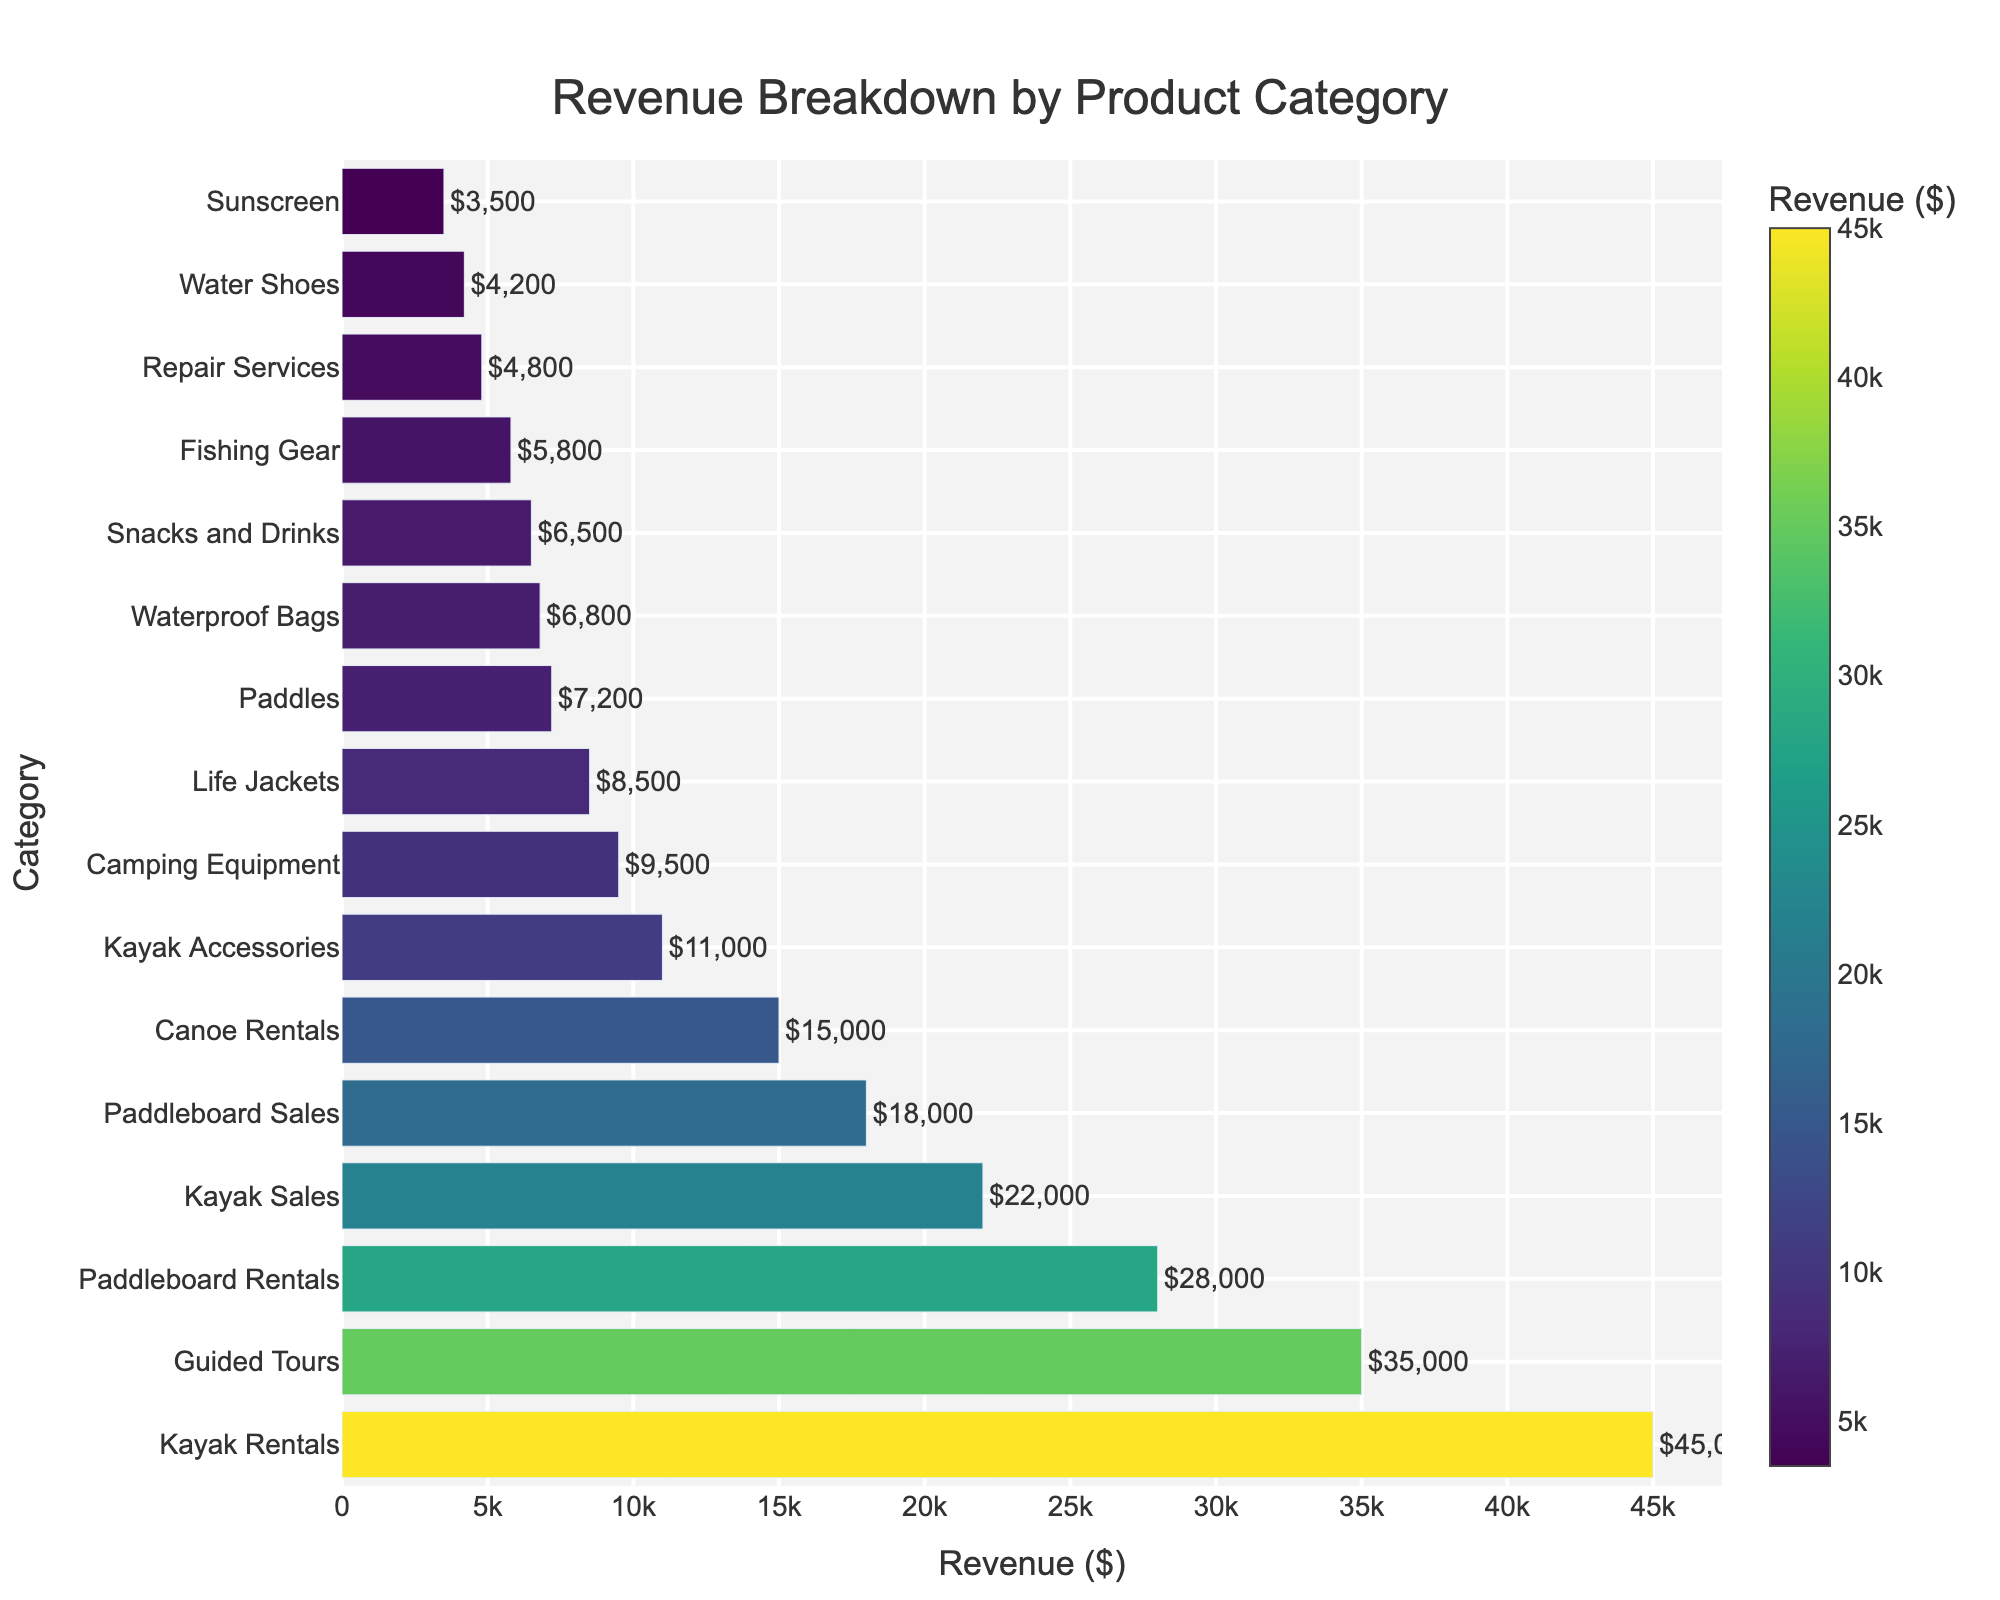Which product category has the highest revenue? By looking at the plot, the bar representing "Kayak Rentals" is the longest, indicating it has the highest revenue.
Answer: Kayak Rentals How much more revenue do "Kayak Rentals" generate compared to "Canoe Rentals"? Kayak Rentals have a revenue of $45,000 and Canoe Rentals have a revenue of $15,000. The difference is $45,000 - $15,000 = $30,000.
Answer: $30,000 What's the combined revenue of "Guided Tours" and "Kayak Sales"? The revenue for Guided Tours is $35,000 and for Kayak Sales, it is $22,000. The combined revenue is $35,000 + $22,000 = $57,000.
Answer: $57,000 Which product category has a revenue closest to $10,000? By examining the bars on the chart, "Kayak Accessories" has a revenue closest to $10,000 with an exact amount of $11,000.
Answer: Kayak Accessories Is the revenue from "Paddleboard Rentals" greater than the revenue from "Kayak Sales"? The revenue from Paddleboard Rentals is $28,000 and the revenue from Kayak Sales is $22,000. $28,000 is greater than $22,000.
Answer: Yes What is the total revenue from the three least profitable categories? The least profitable categories are "Sunscreen" with $3,500, "Repair Services" with $4,800, and "Water Shoes" with $4,200. The total revenue is $3,500 + $4,800 + $4,200 = $12,500.
Answer: $12,500 Which category has a higher revenue: "Snacks and Drinks" or "Fishing Gear"? By comparing the bar lengths, "Snacks and Drinks" have a revenue of $6,500, whereas "Fishing Gear" has a revenue of $5,800.
Answer: Snacks and Drinks How much revenue do the categories related to safety equipment ("Life Jackets" and "Paddles") generate in total? The revenue for Life Jackets is $8,500 and for Paddles, it is $7,200. The combined revenue is $8,500 + $7,200 = $15,700.
Answer: $15,700 Which of the following two categories has a longer bar: "Camping Equipment" or "Waterproof Bags"? The bar for "Camping Equipment" is longer with a revenue of $9,500 compared to "Waterproof Bags" which has a revenue of $6,800.
Answer: Camping Equipment What is the average revenue of "Paddleboard Sales", "Water Shoes" and "Fishing Gear"? "Paddleboard Sales" has a revenue of $18,000, "Water Shoes" has $4,200, and "Fishing Gear" has $5,800. The total revenue is $18,000 + $4,200 + $5,800 = $28,000. The average is $28,000 / 3 = $9,333.
Answer: $9,333 